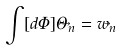<formula> <loc_0><loc_0><loc_500><loc_500>\int [ d \Phi ] \Theta _ { \vec { n } } = w _ { \vec { n } }</formula> 